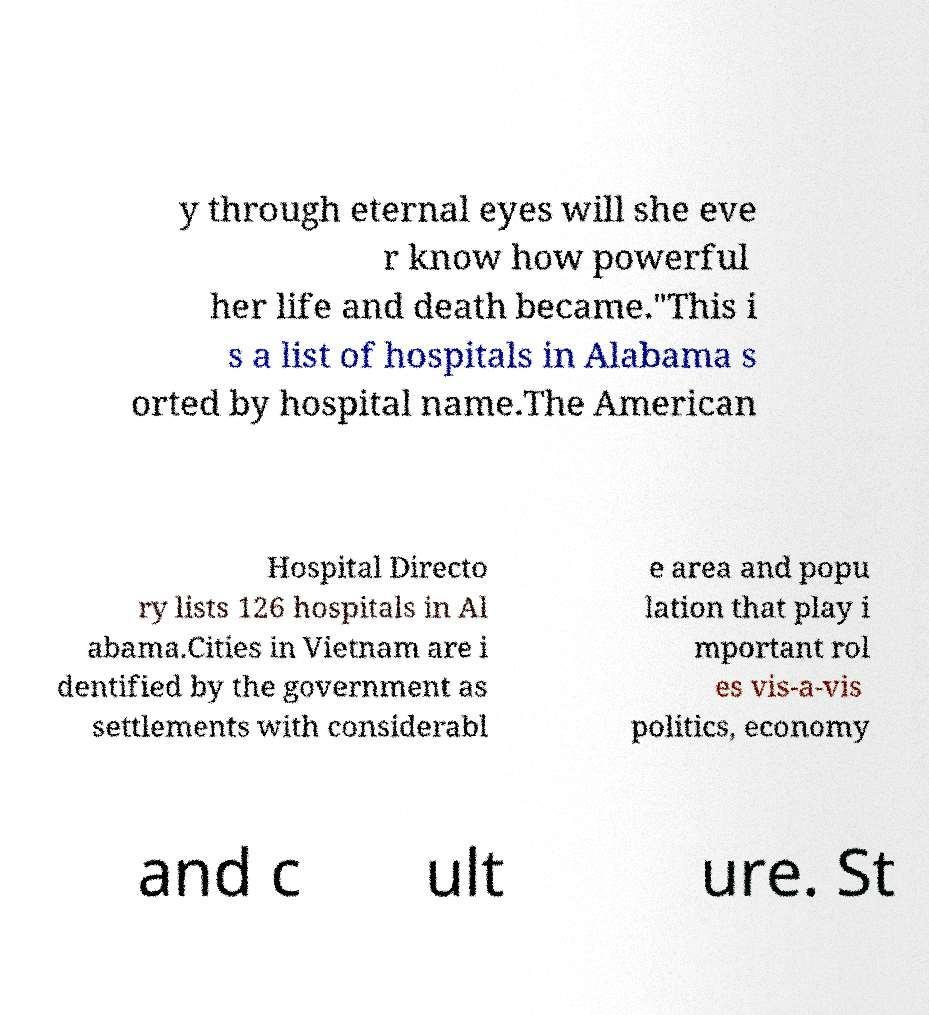Can you accurately transcribe the text from the provided image for me? y through eternal eyes will she eve r know how powerful her life and death became."This i s a list of hospitals in Alabama s orted by hospital name.The American Hospital Directo ry lists 126 hospitals in Al abama.Cities in Vietnam are i dentified by the government as settlements with considerabl e area and popu lation that play i mportant rol es vis-a-vis politics, economy and c ult ure. St 